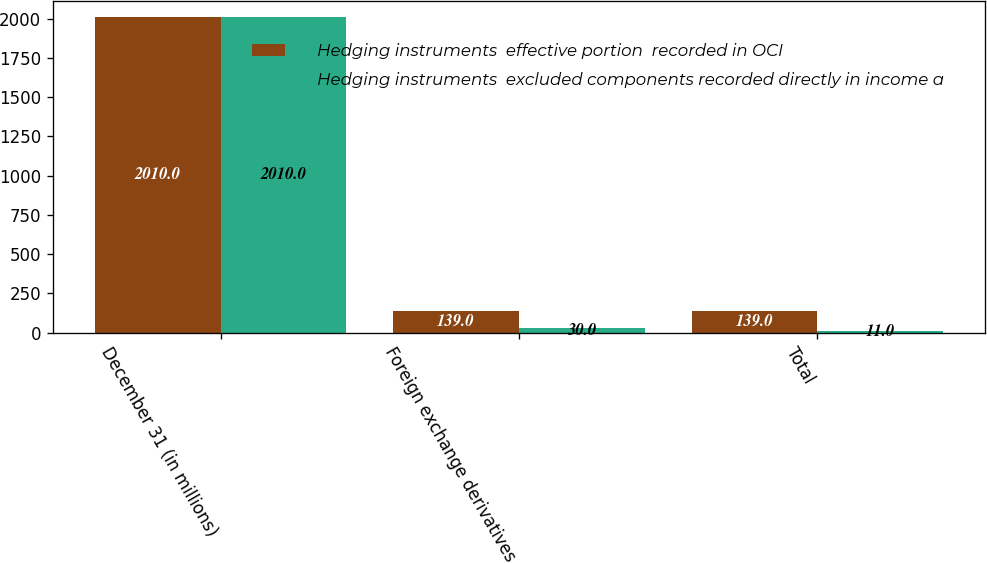Convert chart. <chart><loc_0><loc_0><loc_500><loc_500><stacked_bar_chart><ecel><fcel>December 31 (in millions)<fcel>Foreign exchange derivatives<fcel>Total<nl><fcel>Hedging instruments  effective portion  recorded in OCI<fcel>2010<fcel>139<fcel>139<nl><fcel>Hedging instruments  excluded components recorded directly in income a<fcel>2010<fcel>30<fcel>11<nl></chart> 